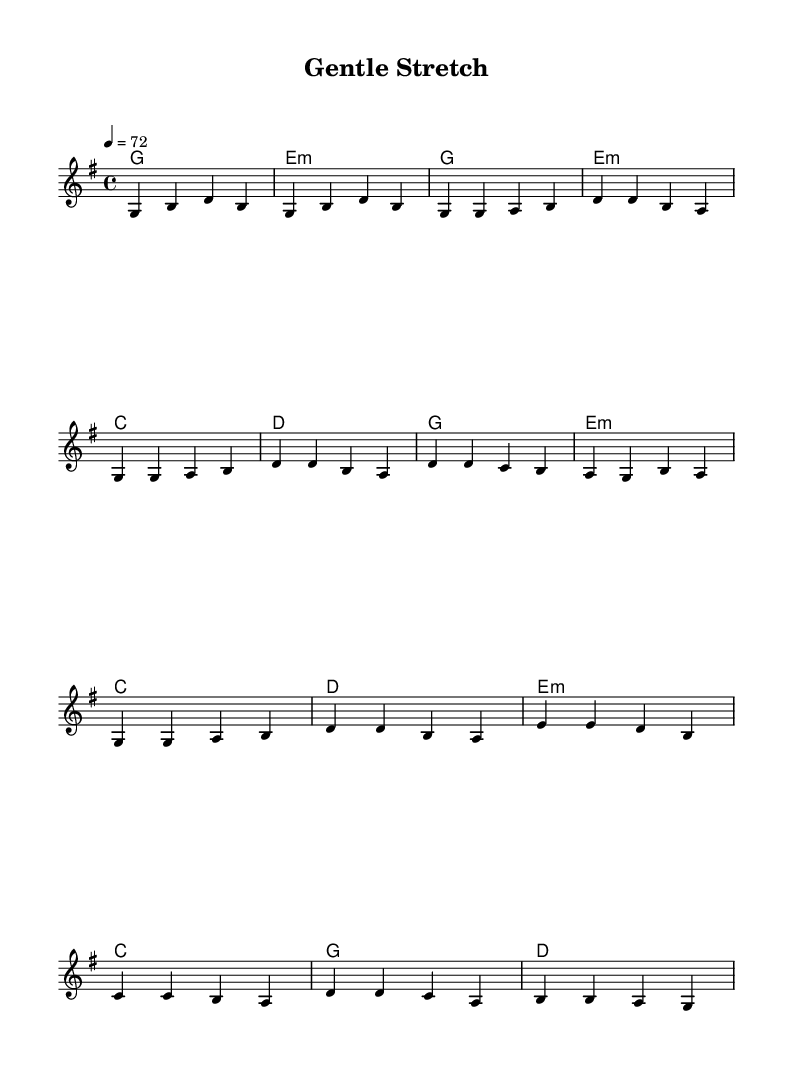What is the key signature of this music? The key signature is G major, which has one sharp, F#. This can be determined by looking at the key signature notation at the beginning of the piece.
Answer: G major What is the time signature of this piece? The time signature is 4/4, meaning there are four beats in each measure and the quarter note gets one beat. This is indicated by the notation that appears right after the key signature.
Answer: 4/4 What tempo marking is indicated in this sheet music? The tempo marking indicates a speed of quarter note equals 72 beats per minute. This can be found in the tempo notation at the beginning of the score.
Answer: 72 How many distinct sections are in this music? There are four distinct sections: Intro, Verse, Chorus, and Bridge. Each section is marked accordingly in the melody pattern.
Answer: Four What is the first chord used in this piece? The first chord is G major, which is represented in the harmonies section at the start of the sheet music. The chord names are written aligned with the melody.
Answer: G major In which section do the notes rise from B to D? The notes rise from B to D in the Chorus section, specifically in the first measure of the Chorus part where the notes ascends from B to D.
Answer: Chorus Which chord follows the E minor in the harmonies during the Bridge? The chord that follows the E minor is C major, as seen in the harmonies section where the E minor chord is immediately followed by the C chord.
Answer: C major 